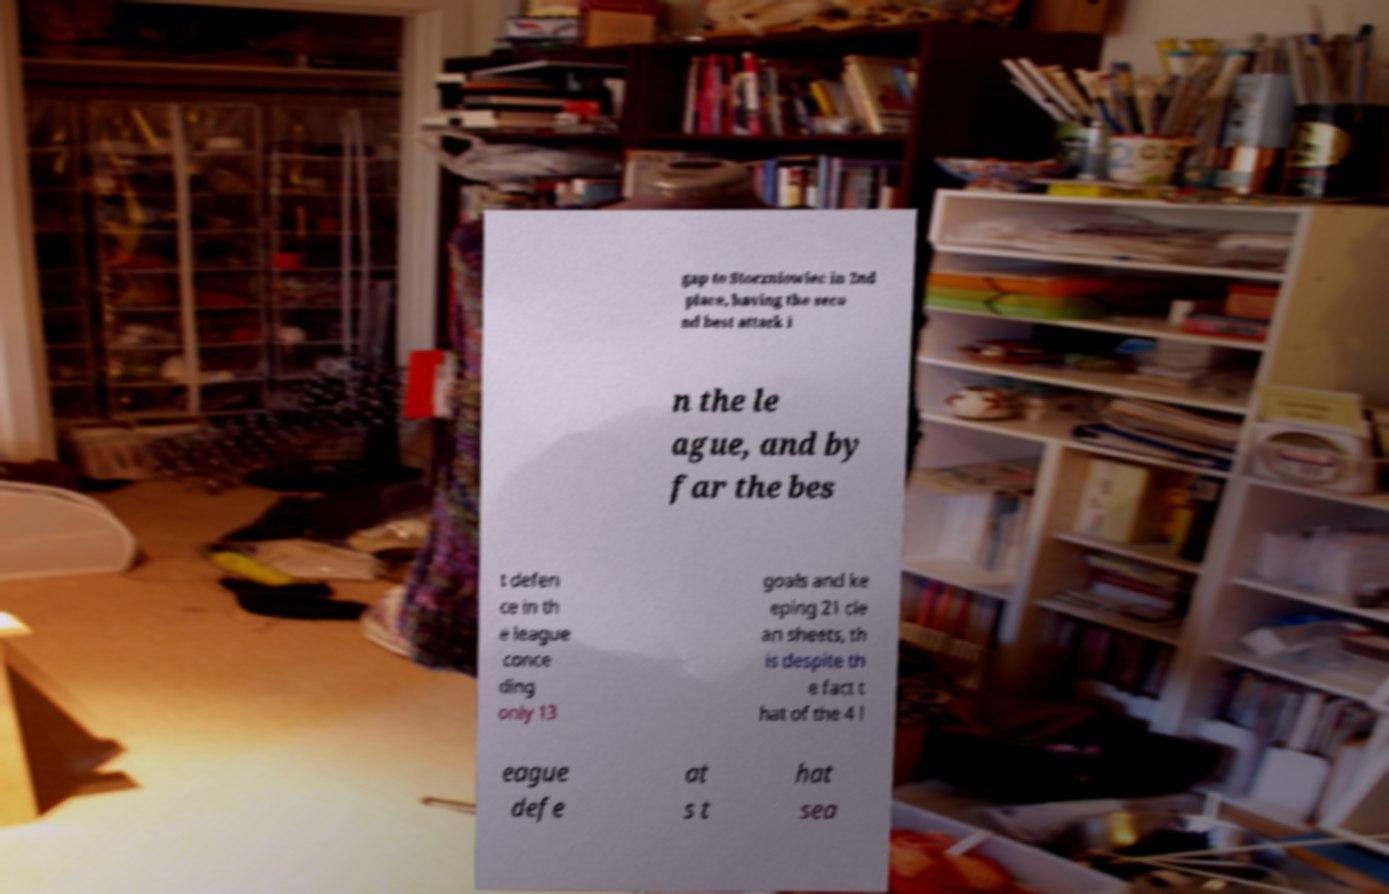Can you read and provide the text displayed in the image?This photo seems to have some interesting text. Can you extract and type it out for me? gap to Stoczniowiec in 2nd place, having the seco nd best attack i n the le ague, and by far the bes t defen ce in th e league conce ding only 13 goals and ke eping 21 cle an sheets, th is despite th e fact t hat of the 4 l eague defe at s t hat sea 